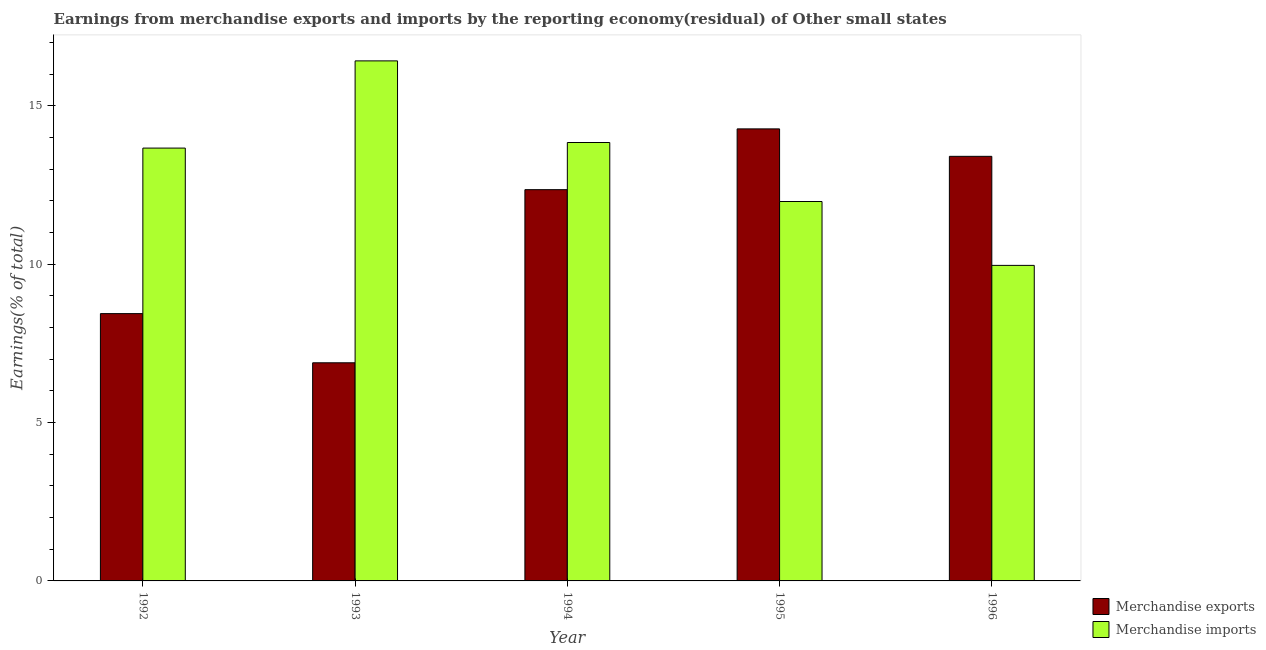How many different coloured bars are there?
Provide a succinct answer. 2. How many groups of bars are there?
Give a very brief answer. 5. Are the number of bars per tick equal to the number of legend labels?
Ensure brevity in your answer.  Yes. How many bars are there on the 2nd tick from the left?
Ensure brevity in your answer.  2. How many bars are there on the 2nd tick from the right?
Your answer should be very brief. 2. What is the label of the 5th group of bars from the left?
Keep it short and to the point. 1996. In how many cases, is the number of bars for a given year not equal to the number of legend labels?
Your answer should be very brief. 0. What is the earnings from merchandise exports in 1994?
Give a very brief answer. 12.35. Across all years, what is the maximum earnings from merchandise exports?
Make the answer very short. 14.27. Across all years, what is the minimum earnings from merchandise exports?
Your answer should be compact. 6.89. What is the total earnings from merchandise imports in the graph?
Make the answer very short. 65.85. What is the difference between the earnings from merchandise imports in 1993 and that in 1995?
Your answer should be very brief. 4.44. What is the difference between the earnings from merchandise exports in 1996 and the earnings from merchandise imports in 1993?
Ensure brevity in your answer.  6.52. What is the average earnings from merchandise exports per year?
Provide a succinct answer. 11.07. In the year 1994, what is the difference between the earnings from merchandise imports and earnings from merchandise exports?
Make the answer very short. 0. In how many years, is the earnings from merchandise exports greater than 9 %?
Your response must be concise. 3. What is the ratio of the earnings from merchandise imports in 1994 to that in 1995?
Provide a short and direct response. 1.16. What is the difference between the highest and the second highest earnings from merchandise imports?
Your response must be concise. 2.58. What is the difference between the highest and the lowest earnings from merchandise imports?
Offer a terse response. 6.46. Is the sum of the earnings from merchandise imports in 1992 and 1994 greater than the maximum earnings from merchandise exports across all years?
Provide a short and direct response. Yes. What does the 2nd bar from the left in 1995 represents?
Offer a terse response. Merchandise imports. How many bars are there?
Your answer should be compact. 10. How many years are there in the graph?
Provide a short and direct response. 5. What is the difference between two consecutive major ticks on the Y-axis?
Give a very brief answer. 5. Are the values on the major ticks of Y-axis written in scientific E-notation?
Offer a terse response. No. Does the graph contain any zero values?
Give a very brief answer. No. How many legend labels are there?
Provide a short and direct response. 2. How are the legend labels stacked?
Keep it short and to the point. Vertical. What is the title of the graph?
Keep it short and to the point. Earnings from merchandise exports and imports by the reporting economy(residual) of Other small states. What is the label or title of the X-axis?
Offer a very short reply. Year. What is the label or title of the Y-axis?
Provide a succinct answer. Earnings(% of total). What is the Earnings(% of total) in Merchandise exports in 1992?
Your answer should be compact. 8.44. What is the Earnings(% of total) of Merchandise imports in 1992?
Make the answer very short. 13.66. What is the Earnings(% of total) in Merchandise exports in 1993?
Offer a terse response. 6.89. What is the Earnings(% of total) of Merchandise imports in 1993?
Offer a terse response. 16.42. What is the Earnings(% of total) of Merchandise exports in 1994?
Ensure brevity in your answer.  12.35. What is the Earnings(% of total) of Merchandise imports in 1994?
Provide a succinct answer. 13.84. What is the Earnings(% of total) in Merchandise exports in 1995?
Keep it short and to the point. 14.27. What is the Earnings(% of total) in Merchandise imports in 1995?
Your answer should be compact. 11.98. What is the Earnings(% of total) of Merchandise exports in 1996?
Make the answer very short. 13.4. What is the Earnings(% of total) of Merchandise imports in 1996?
Ensure brevity in your answer.  9.96. Across all years, what is the maximum Earnings(% of total) in Merchandise exports?
Provide a succinct answer. 14.27. Across all years, what is the maximum Earnings(% of total) of Merchandise imports?
Offer a terse response. 16.42. Across all years, what is the minimum Earnings(% of total) in Merchandise exports?
Give a very brief answer. 6.89. Across all years, what is the minimum Earnings(% of total) in Merchandise imports?
Provide a succinct answer. 9.96. What is the total Earnings(% of total) of Merchandise exports in the graph?
Provide a succinct answer. 55.35. What is the total Earnings(% of total) of Merchandise imports in the graph?
Provide a short and direct response. 65.86. What is the difference between the Earnings(% of total) in Merchandise exports in 1992 and that in 1993?
Your answer should be compact. 1.55. What is the difference between the Earnings(% of total) in Merchandise imports in 1992 and that in 1993?
Offer a terse response. -2.75. What is the difference between the Earnings(% of total) of Merchandise exports in 1992 and that in 1994?
Provide a succinct answer. -3.91. What is the difference between the Earnings(% of total) of Merchandise imports in 1992 and that in 1994?
Make the answer very short. -0.18. What is the difference between the Earnings(% of total) of Merchandise exports in 1992 and that in 1995?
Provide a short and direct response. -5.83. What is the difference between the Earnings(% of total) in Merchandise imports in 1992 and that in 1995?
Ensure brevity in your answer.  1.69. What is the difference between the Earnings(% of total) in Merchandise exports in 1992 and that in 1996?
Provide a succinct answer. -4.96. What is the difference between the Earnings(% of total) of Merchandise imports in 1992 and that in 1996?
Offer a terse response. 3.7. What is the difference between the Earnings(% of total) of Merchandise exports in 1993 and that in 1994?
Give a very brief answer. -5.47. What is the difference between the Earnings(% of total) of Merchandise imports in 1993 and that in 1994?
Offer a terse response. 2.58. What is the difference between the Earnings(% of total) in Merchandise exports in 1993 and that in 1995?
Provide a succinct answer. -7.38. What is the difference between the Earnings(% of total) of Merchandise imports in 1993 and that in 1995?
Ensure brevity in your answer.  4.44. What is the difference between the Earnings(% of total) of Merchandise exports in 1993 and that in 1996?
Make the answer very short. -6.52. What is the difference between the Earnings(% of total) in Merchandise imports in 1993 and that in 1996?
Provide a short and direct response. 6.46. What is the difference between the Earnings(% of total) of Merchandise exports in 1994 and that in 1995?
Offer a very short reply. -1.92. What is the difference between the Earnings(% of total) in Merchandise imports in 1994 and that in 1995?
Keep it short and to the point. 1.86. What is the difference between the Earnings(% of total) of Merchandise exports in 1994 and that in 1996?
Keep it short and to the point. -1.05. What is the difference between the Earnings(% of total) in Merchandise imports in 1994 and that in 1996?
Your answer should be very brief. 3.88. What is the difference between the Earnings(% of total) in Merchandise exports in 1995 and that in 1996?
Keep it short and to the point. 0.87. What is the difference between the Earnings(% of total) of Merchandise imports in 1995 and that in 1996?
Offer a very short reply. 2.02. What is the difference between the Earnings(% of total) in Merchandise exports in 1992 and the Earnings(% of total) in Merchandise imports in 1993?
Offer a very short reply. -7.98. What is the difference between the Earnings(% of total) in Merchandise exports in 1992 and the Earnings(% of total) in Merchandise imports in 1994?
Offer a terse response. -5.4. What is the difference between the Earnings(% of total) of Merchandise exports in 1992 and the Earnings(% of total) of Merchandise imports in 1995?
Offer a terse response. -3.54. What is the difference between the Earnings(% of total) in Merchandise exports in 1992 and the Earnings(% of total) in Merchandise imports in 1996?
Offer a very short reply. -1.52. What is the difference between the Earnings(% of total) of Merchandise exports in 1993 and the Earnings(% of total) of Merchandise imports in 1994?
Your answer should be compact. -6.95. What is the difference between the Earnings(% of total) of Merchandise exports in 1993 and the Earnings(% of total) of Merchandise imports in 1995?
Give a very brief answer. -5.09. What is the difference between the Earnings(% of total) of Merchandise exports in 1993 and the Earnings(% of total) of Merchandise imports in 1996?
Provide a short and direct response. -3.07. What is the difference between the Earnings(% of total) of Merchandise exports in 1994 and the Earnings(% of total) of Merchandise imports in 1995?
Your answer should be very brief. 0.37. What is the difference between the Earnings(% of total) of Merchandise exports in 1994 and the Earnings(% of total) of Merchandise imports in 1996?
Keep it short and to the point. 2.39. What is the difference between the Earnings(% of total) in Merchandise exports in 1995 and the Earnings(% of total) in Merchandise imports in 1996?
Offer a terse response. 4.31. What is the average Earnings(% of total) of Merchandise exports per year?
Offer a terse response. 11.07. What is the average Earnings(% of total) of Merchandise imports per year?
Ensure brevity in your answer.  13.17. In the year 1992, what is the difference between the Earnings(% of total) of Merchandise exports and Earnings(% of total) of Merchandise imports?
Give a very brief answer. -5.23. In the year 1993, what is the difference between the Earnings(% of total) in Merchandise exports and Earnings(% of total) in Merchandise imports?
Offer a very short reply. -9.53. In the year 1994, what is the difference between the Earnings(% of total) of Merchandise exports and Earnings(% of total) of Merchandise imports?
Offer a very short reply. -1.49. In the year 1995, what is the difference between the Earnings(% of total) in Merchandise exports and Earnings(% of total) in Merchandise imports?
Ensure brevity in your answer.  2.29. In the year 1996, what is the difference between the Earnings(% of total) of Merchandise exports and Earnings(% of total) of Merchandise imports?
Provide a short and direct response. 3.44. What is the ratio of the Earnings(% of total) in Merchandise exports in 1992 to that in 1993?
Keep it short and to the point. 1.23. What is the ratio of the Earnings(% of total) of Merchandise imports in 1992 to that in 1993?
Offer a terse response. 0.83. What is the ratio of the Earnings(% of total) of Merchandise exports in 1992 to that in 1994?
Keep it short and to the point. 0.68. What is the ratio of the Earnings(% of total) of Merchandise imports in 1992 to that in 1994?
Provide a short and direct response. 0.99. What is the ratio of the Earnings(% of total) in Merchandise exports in 1992 to that in 1995?
Provide a short and direct response. 0.59. What is the ratio of the Earnings(% of total) in Merchandise imports in 1992 to that in 1995?
Provide a short and direct response. 1.14. What is the ratio of the Earnings(% of total) in Merchandise exports in 1992 to that in 1996?
Offer a very short reply. 0.63. What is the ratio of the Earnings(% of total) in Merchandise imports in 1992 to that in 1996?
Provide a succinct answer. 1.37. What is the ratio of the Earnings(% of total) of Merchandise exports in 1993 to that in 1994?
Give a very brief answer. 0.56. What is the ratio of the Earnings(% of total) in Merchandise imports in 1993 to that in 1994?
Your answer should be very brief. 1.19. What is the ratio of the Earnings(% of total) of Merchandise exports in 1993 to that in 1995?
Provide a succinct answer. 0.48. What is the ratio of the Earnings(% of total) of Merchandise imports in 1993 to that in 1995?
Provide a succinct answer. 1.37. What is the ratio of the Earnings(% of total) of Merchandise exports in 1993 to that in 1996?
Keep it short and to the point. 0.51. What is the ratio of the Earnings(% of total) of Merchandise imports in 1993 to that in 1996?
Keep it short and to the point. 1.65. What is the ratio of the Earnings(% of total) of Merchandise exports in 1994 to that in 1995?
Offer a terse response. 0.87. What is the ratio of the Earnings(% of total) of Merchandise imports in 1994 to that in 1995?
Make the answer very short. 1.16. What is the ratio of the Earnings(% of total) of Merchandise exports in 1994 to that in 1996?
Keep it short and to the point. 0.92. What is the ratio of the Earnings(% of total) of Merchandise imports in 1994 to that in 1996?
Ensure brevity in your answer.  1.39. What is the ratio of the Earnings(% of total) in Merchandise exports in 1995 to that in 1996?
Give a very brief answer. 1.06. What is the ratio of the Earnings(% of total) of Merchandise imports in 1995 to that in 1996?
Provide a succinct answer. 1.2. What is the difference between the highest and the second highest Earnings(% of total) in Merchandise exports?
Offer a terse response. 0.87. What is the difference between the highest and the second highest Earnings(% of total) of Merchandise imports?
Your response must be concise. 2.58. What is the difference between the highest and the lowest Earnings(% of total) of Merchandise exports?
Keep it short and to the point. 7.38. What is the difference between the highest and the lowest Earnings(% of total) of Merchandise imports?
Offer a very short reply. 6.46. 